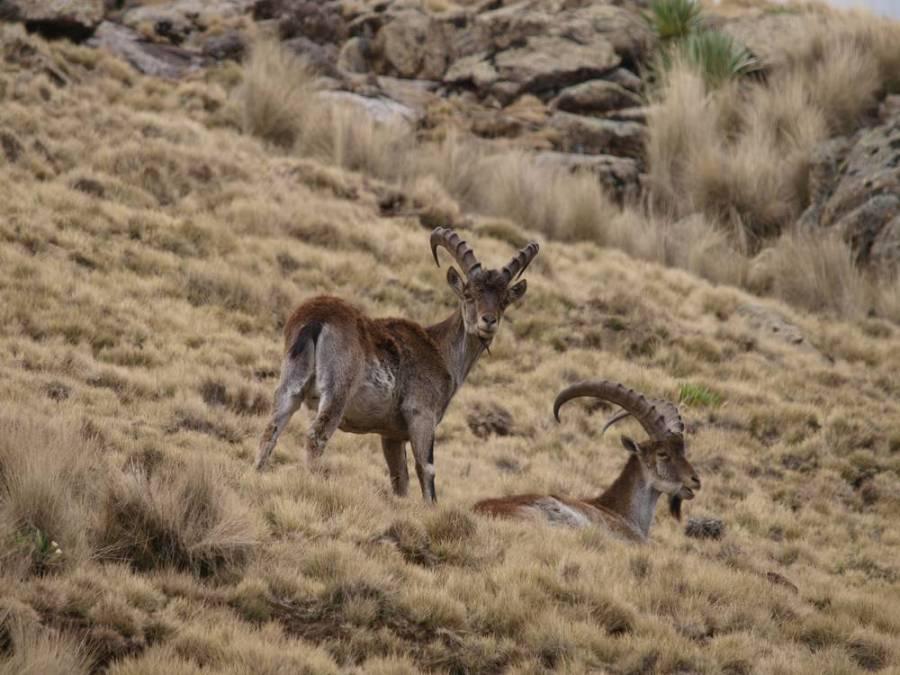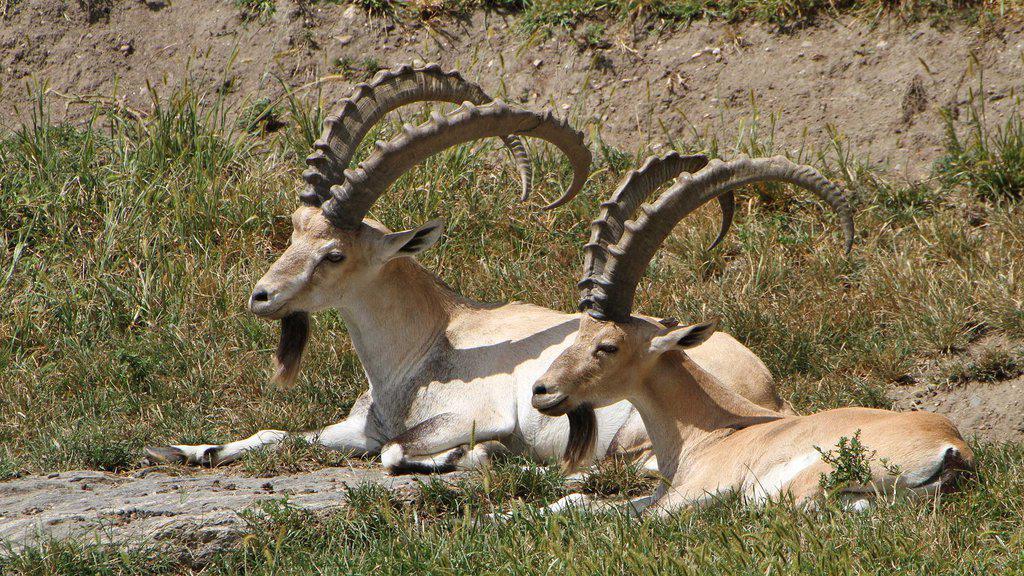The first image is the image on the left, the second image is the image on the right. For the images displayed, is the sentence "No image contains more than three hooved animals." factually correct? Answer yes or no. Yes. The first image is the image on the left, the second image is the image on the right. Assess this claim about the two images: "The two animals in the image on the left are horned.". Correct or not? Answer yes or no. Yes. 